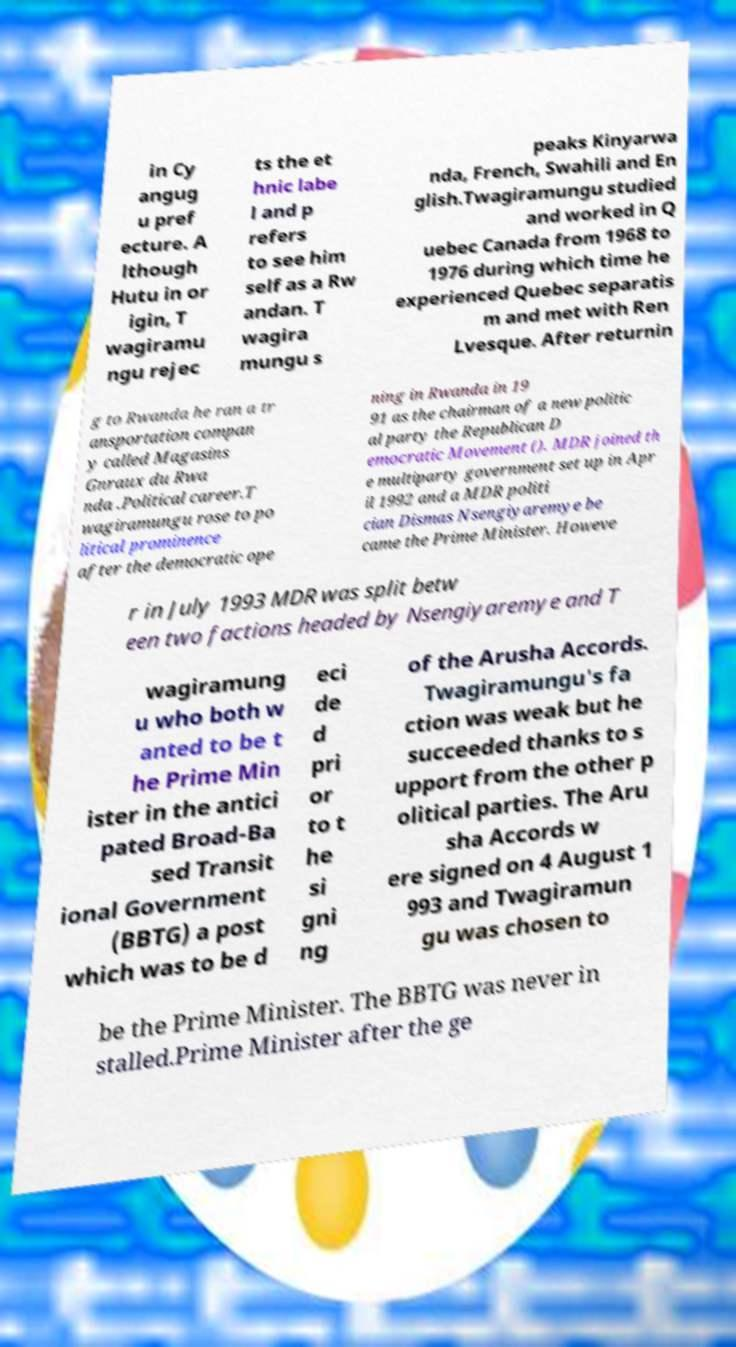Could you assist in decoding the text presented in this image and type it out clearly? in Cy angug u pref ecture. A lthough Hutu in or igin, T wagiramu ngu rejec ts the et hnic labe l and p refers to see him self as a Rw andan. T wagira mungu s peaks Kinyarwa nda, French, Swahili and En glish.Twagiramungu studied and worked in Q uebec Canada from 1968 to 1976 during which time he experienced Quebec separatis m and met with Ren Lvesque. After returnin g to Rwanda he ran a tr ansportation compan y called Magasins Gnraux du Rwa nda .Political career.T wagiramungu rose to po litical prominence after the democratic ope ning in Rwanda in 19 91 as the chairman of a new politic al party the Republican D emocratic Movement (). MDR joined th e multiparty government set up in Apr il 1992 and a MDR politi cian Dismas Nsengiyaremye be came the Prime Minister. Howeve r in July 1993 MDR was split betw een two factions headed by Nsengiyaremye and T wagiramung u who both w anted to be t he Prime Min ister in the antici pated Broad-Ba sed Transit ional Government (BBTG) a post which was to be d eci de d pri or to t he si gni ng of the Arusha Accords. Twagiramungu's fa ction was weak but he succeeded thanks to s upport from the other p olitical parties. The Aru sha Accords w ere signed on 4 August 1 993 and Twagiramun gu was chosen to be the Prime Minister. The BBTG was never in stalled.Prime Minister after the ge 